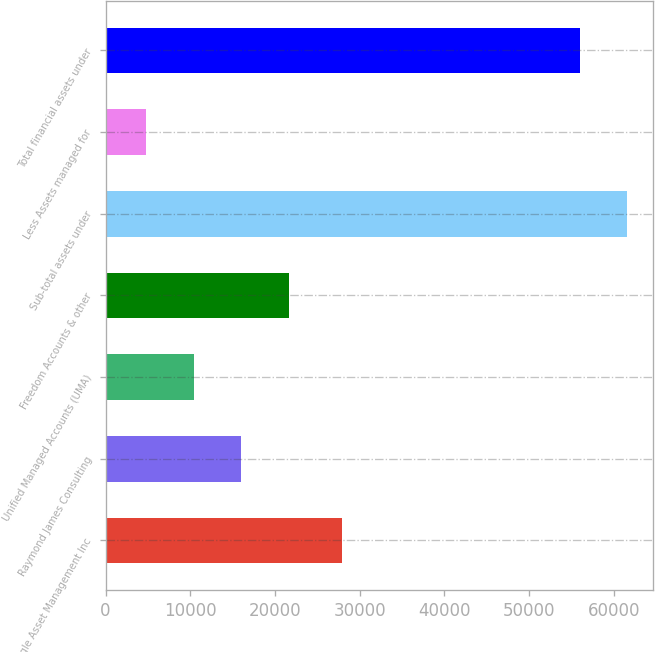<chart> <loc_0><loc_0><loc_500><loc_500><bar_chart><fcel>Eagle Asset Management Inc<fcel>Raymond James Consulting<fcel>Unified Managed Accounts (UMA)<fcel>Freedom Accounts & other<fcel>Sub-total assets under<fcel>Less Assets managed for<fcel>Total financial assets under<nl><fcel>27886<fcel>15996.8<fcel>10397.9<fcel>21595.7<fcel>61587.9<fcel>4799<fcel>55989<nl></chart> 